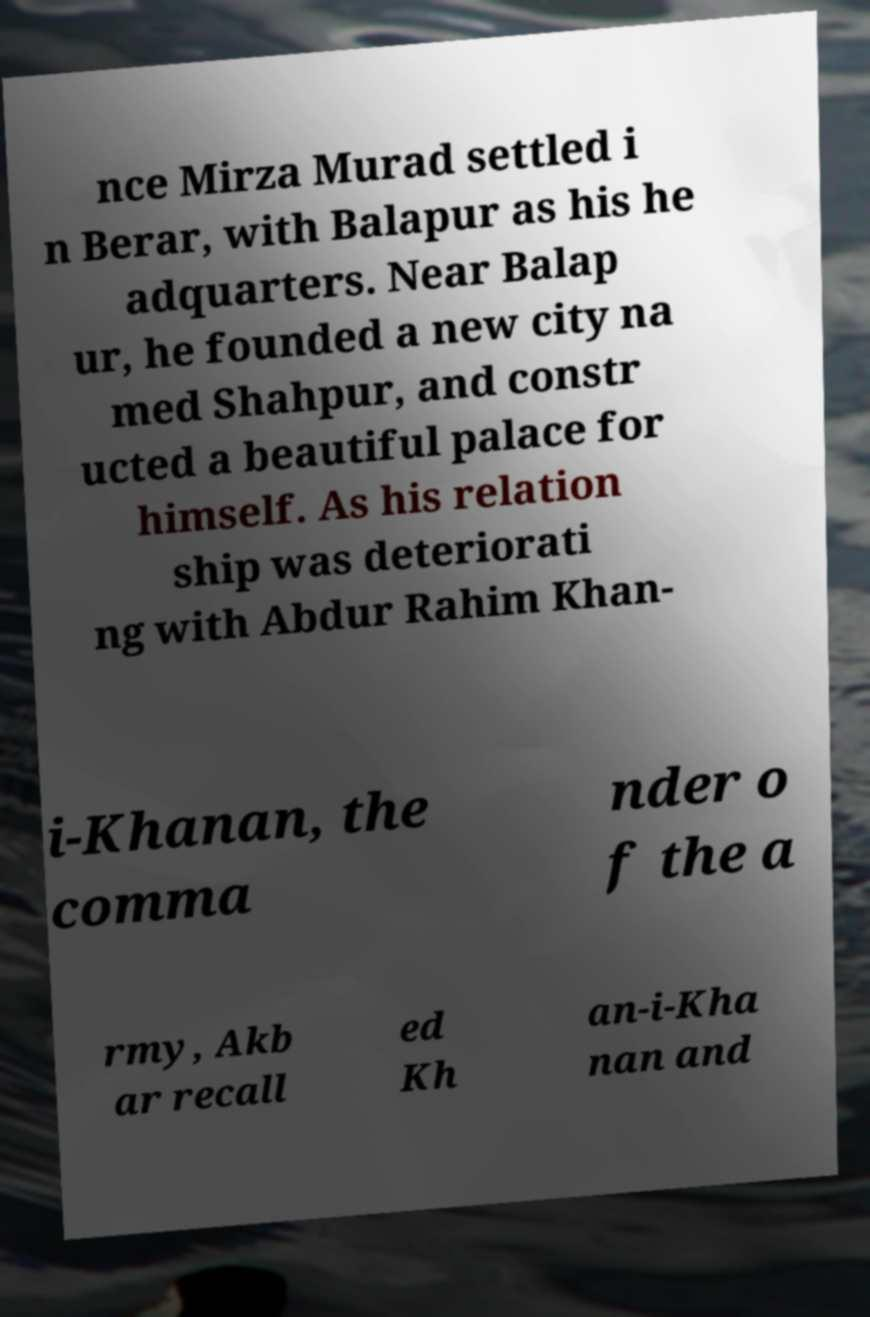Please read and relay the text visible in this image. What does it say? nce Mirza Murad settled i n Berar, with Balapur as his he adquarters. Near Balap ur, he founded a new city na med Shahpur, and constr ucted a beautiful palace for himself. As his relation ship was deteriorati ng with Abdur Rahim Khan- i-Khanan, the comma nder o f the a rmy, Akb ar recall ed Kh an-i-Kha nan and 